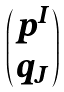<formula> <loc_0><loc_0><loc_500><loc_500>\begin{pmatrix} p ^ { I } \\ q _ { J } \end{pmatrix}</formula> 